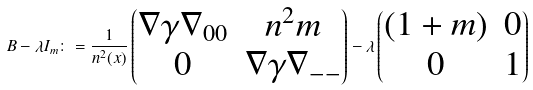<formula> <loc_0><loc_0><loc_500><loc_500>B - \lambda I _ { m } \colon = \frac { 1 } { n ^ { 2 } ( x ) } \begin{pmatrix} \nabla \gamma \nabla _ { 0 0 } & n ^ { 2 } m \\ 0 & \nabla \gamma \nabla _ { - - } \end{pmatrix} - \lambda \begin{pmatrix} ( 1 + m ) & 0 \\ 0 & 1 \end{pmatrix}</formula> 